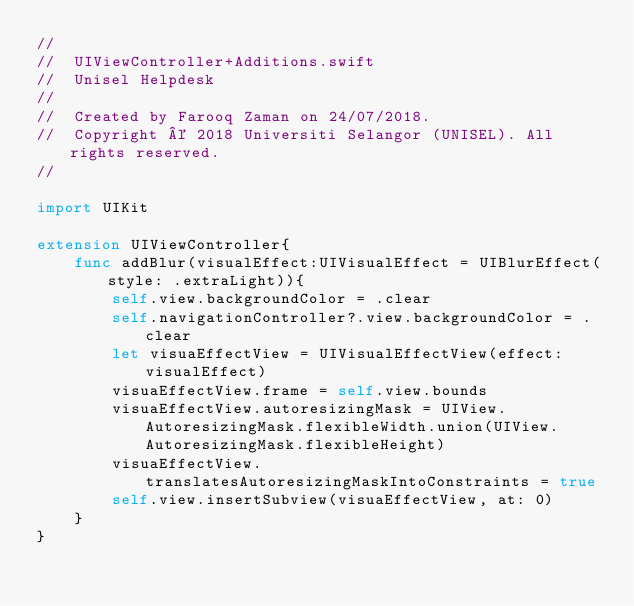<code> <loc_0><loc_0><loc_500><loc_500><_Swift_>//
//  UIViewController+Additions.swift
//  Unisel Helpdesk
//
//  Created by Farooq Zaman on 24/07/2018.
//  Copyright © 2018 Universiti Selangor (UNISEL). All rights reserved.
//

import UIKit

extension UIViewController{
    func addBlur(visualEffect:UIVisualEffect = UIBlurEffect(style: .extraLight)){
        self.view.backgroundColor = .clear
        self.navigationController?.view.backgroundColor = .clear
        let visuaEffectView = UIVisualEffectView(effect: visualEffect)
        visuaEffectView.frame = self.view.bounds
        visuaEffectView.autoresizingMask = UIView.AutoresizingMask.flexibleWidth.union(UIView.AutoresizingMask.flexibleHeight)
        visuaEffectView.translatesAutoresizingMaskIntoConstraints = true
        self.view.insertSubview(visuaEffectView, at: 0)
    }
}
</code> 